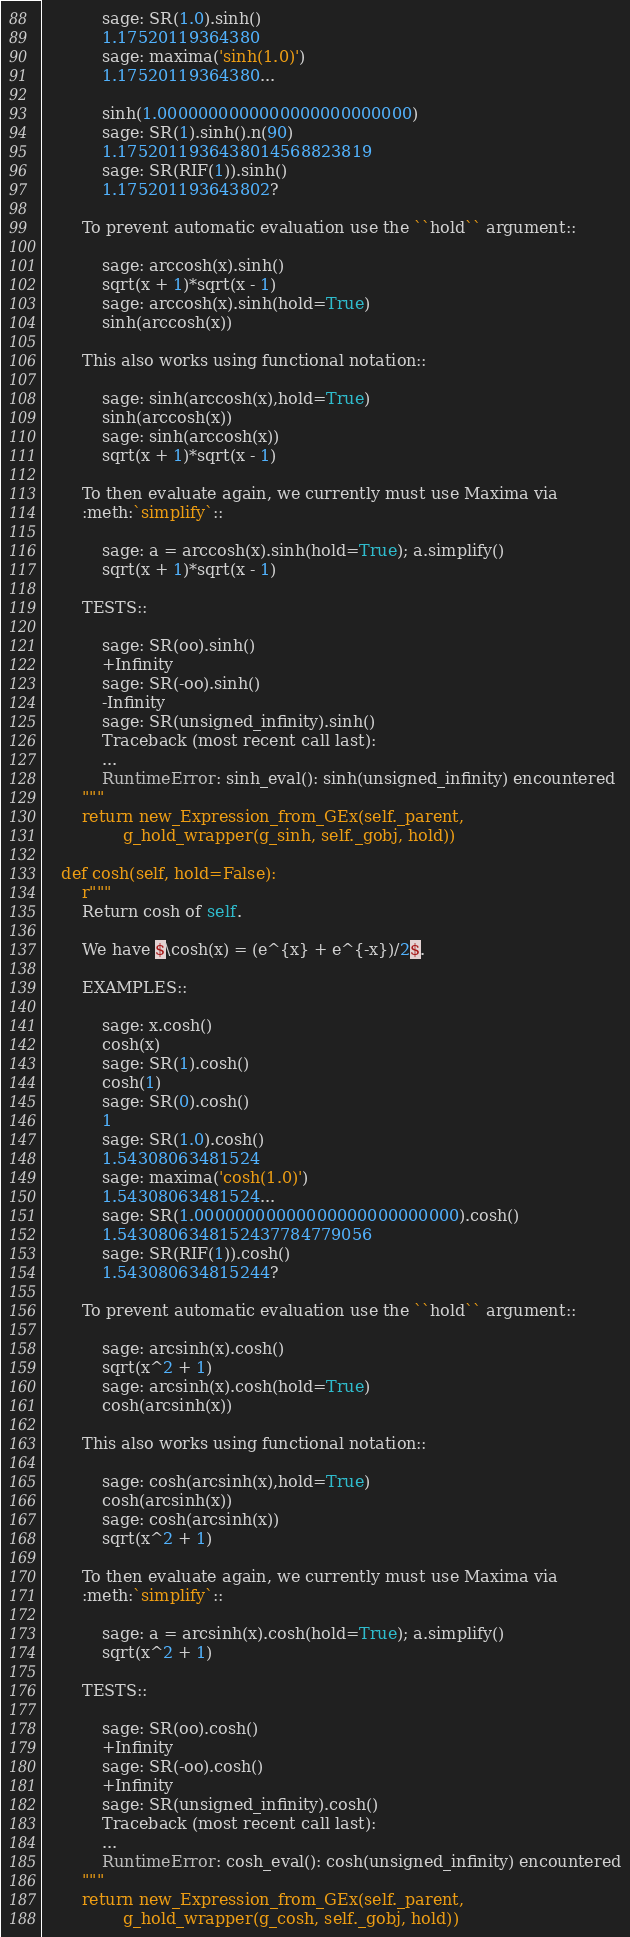Convert code to text. <code><loc_0><loc_0><loc_500><loc_500><_Cython_>            sage: SR(1.0).sinh()
            1.17520119364380
            sage: maxima('sinh(1.0)')
            1.17520119364380...

            sinh(1.0000000000000000000000000)
            sage: SR(1).sinh().n(90)
            1.1752011936438014568823819
            sage: SR(RIF(1)).sinh()
            1.175201193643802?

        To prevent automatic evaluation use the ``hold`` argument::

            sage: arccosh(x).sinh()
            sqrt(x + 1)*sqrt(x - 1)
            sage: arccosh(x).sinh(hold=True)
            sinh(arccosh(x))

        This also works using functional notation::

            sage: sinh(arccosh(x),hold=True)
            sinh(arccosh(x))
            sage: sinh(arccosh(x))
            sqrt(x + 1)*sqrt(x - 1)

        To then evaluate again, we currently must use Maxima via
        :meth:`simplify`::

            sage: a = arccosh(x).sinh(hold=True); a.simplify()
            sqrt(x + 1)*sqrt(x - 1)

        TESTS::

            sage: SR(oo).sinh()
            +Infinity
            sage: SR(-oo).sinh()
            -Infinity
            sage: SR(unsigned_infinity).sinh()
            Traceback (most recent call last):
            ...
            RuntimeError: sinh_eval(): sinh(unsigned_infinity) encountered
        """
        return new_Expression_from_GEx(self._parent,
                g_hold_wrapper(g_sinh, self._gobj, hold))

    def cosh(self, hold=False):
        r"""
        Return cosh of self.

        We have $\cosh(x) = (e^{x} + e^{-x})/2$.

        EXAMPLES::

            sage: x.cosh()
            cosh(x)
            sage: SR(1).cosh()
            cosh(1)
            sage: SR(0).cosh()
            1
            sage: SR(1.0).cosh()
            1.54308063481524
            sage: maxima('cosh(1.0)')
            1.54308063481524...
            sage: SR(1.00000000000000000000000000).cosh()
            1.5430806348152437784779056
            sage: SR(RIF(1)).cosh()
            1.543080634815244?

        To prevent automatic evaluation use the ``hold`` argument::

            sage: arcsinh(x).cosh()
            sqrt(x^2 + 1)
            sage: arcsinh(x).cosh(hold=True)
            cosh(arcsinh(x))

        This also works using functional notation::

            sage: cosh(arcsinh(x),hold=True)
            cosh(arcsinh(x))
            sage: cosh(arcsinh(x))
            sqrt(x^2 + 1)

        To then evaluate again, we currently must use Maxima via
        :meth:`simplify`::

            sage: a = arcsinh(x).cosh(hold=True); a.simplify()
            sqrt(x^2 + 1)

        TESTS::

            sage: SR(oo).cosh()
            +Infinity
            sage: SR(-oo).cosh()
            +Infinity
            sage: SR(unsigned_infinity).cosh()
            Traceback (most recent call last):
            ...
            RuntimeError: cosh_eval(): cosh(unsigned_infinity) encountered
        """
        return new_Expression_from_GEx(self._parent,
                g_hold_wrapper(g_cosh, self._gobj, hold))
</code> 